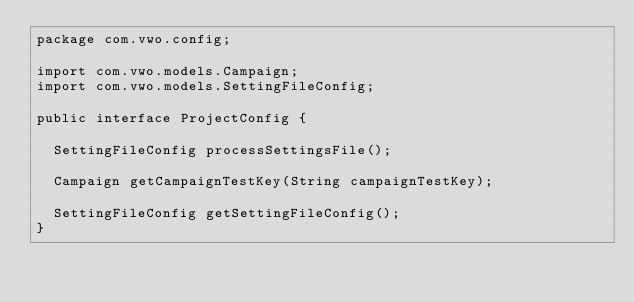Convert code to text. <code><loc_0><loc_0><loc_500><loc_500><_Java_>package com.vwo.config;

import com.vwo.models.Campaign;
import com.vwo.models.SettingFileConfig;

public interface ProjectConfig {

  SettingFileConfig processSettingsFile();

  Campaign getCampaignTestKey(String campaignTestKey);

  SettingFileConfig getSettingFileConfig();
}
</code> 